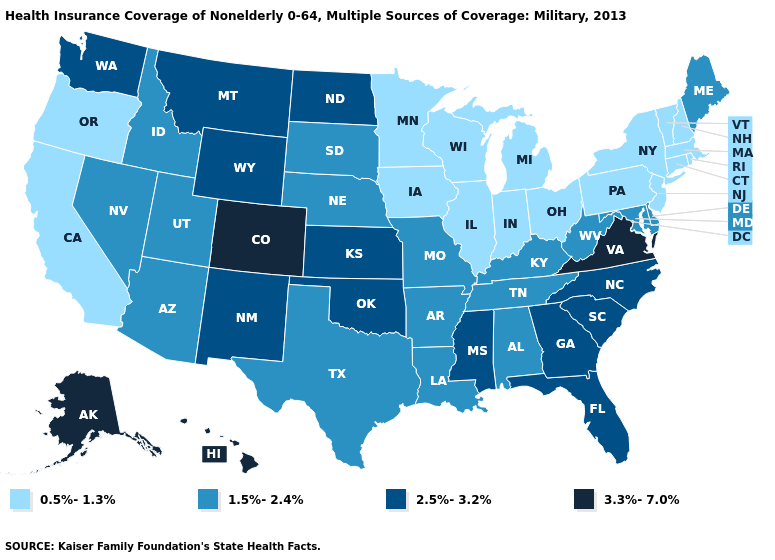Name the states that have a value in the range 1.5%-2.4%?
Give a very brief answer. Alabama, Arizona, Arkansas, Delaware, Idaho, Kentucky, Louisiana, Maine, Maryland, Missouri, Nebraska, Nevada, South Dakota, Tennessee, Texas, Utah, West Virginia. Which states have the lowest value in the Northeast?
Be succinct. Connecticut, Massachusetts, New Hampshire, New Jersey, New York, Pennsylvania, Rhode Island, Vermont. Does Delaware have the same value as Alaska?
Concise answer only. No. Name the states that have a value in the range 3.3%-7.0%?
Concise answer only. Alaska, Colorado, Hawaii, Virginia. Name the states that have a value in the range 1.5%-2.4%?
Be succinct. Alabama, Arizona, Arkansas, Delaware, Idaho, Kentucky, Louisiana, Maine, Maryland, Missouri, Nebraska, Nevada, South Dakota, Tennessee, Texas, Utah, West Virginia. What is the lowest value in the South?
Write a very short answer. 1.5%-2.4%. Among the states that border New Mexico , which have the lowest value?
Give a very brief answer. Arizona, Texas, Utah. Does Alaska have the highest value in the USA?
Write a very short answer. Yes. What is the value of Michigan?
Be succinct. 0.5%-1.3%. Does the first symbol in the legend represent the smallest category?
Short answer required. Yes. What is the value of New Mexico?
Concise answer only. 2.5%-3.2%. Is the legend a continuous bar?
Write a very short answer. No. Among the states that border Iowa , which have the highest value?
Be succinct. Missouri, Nebraska, South Dakota. Name the states that have a value in the range 1.5%-2.4%?
Answer briefly. Alabama, Arizona, Arkansas, Delaware, Idaho, Kentucky, Louisiana, Maine, Maryland, Missouri, Nebraska, Nevada, South Dakota, Tennessee, Texas, Utah, West Virginia. 